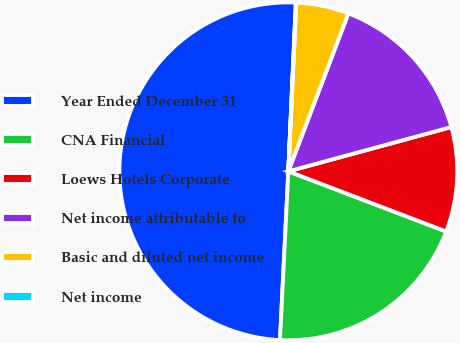Convert chart to OTSL. <chart><loc_0><loc_0><loc_500><loc_500><pie_chart><fcel>Year Ended December 31<fcel>CNA Financial<fcel>Loews Hotels Corporate<fcel>Net income attributable to<fcel>Basic and diluted net income<fcel>Net income<nl><fcel>49.92%<fcel>19.99%<fcel>10.02%<fcel>15.0%<fcel>5.03%<fcel>0.04%<nl></chart> 